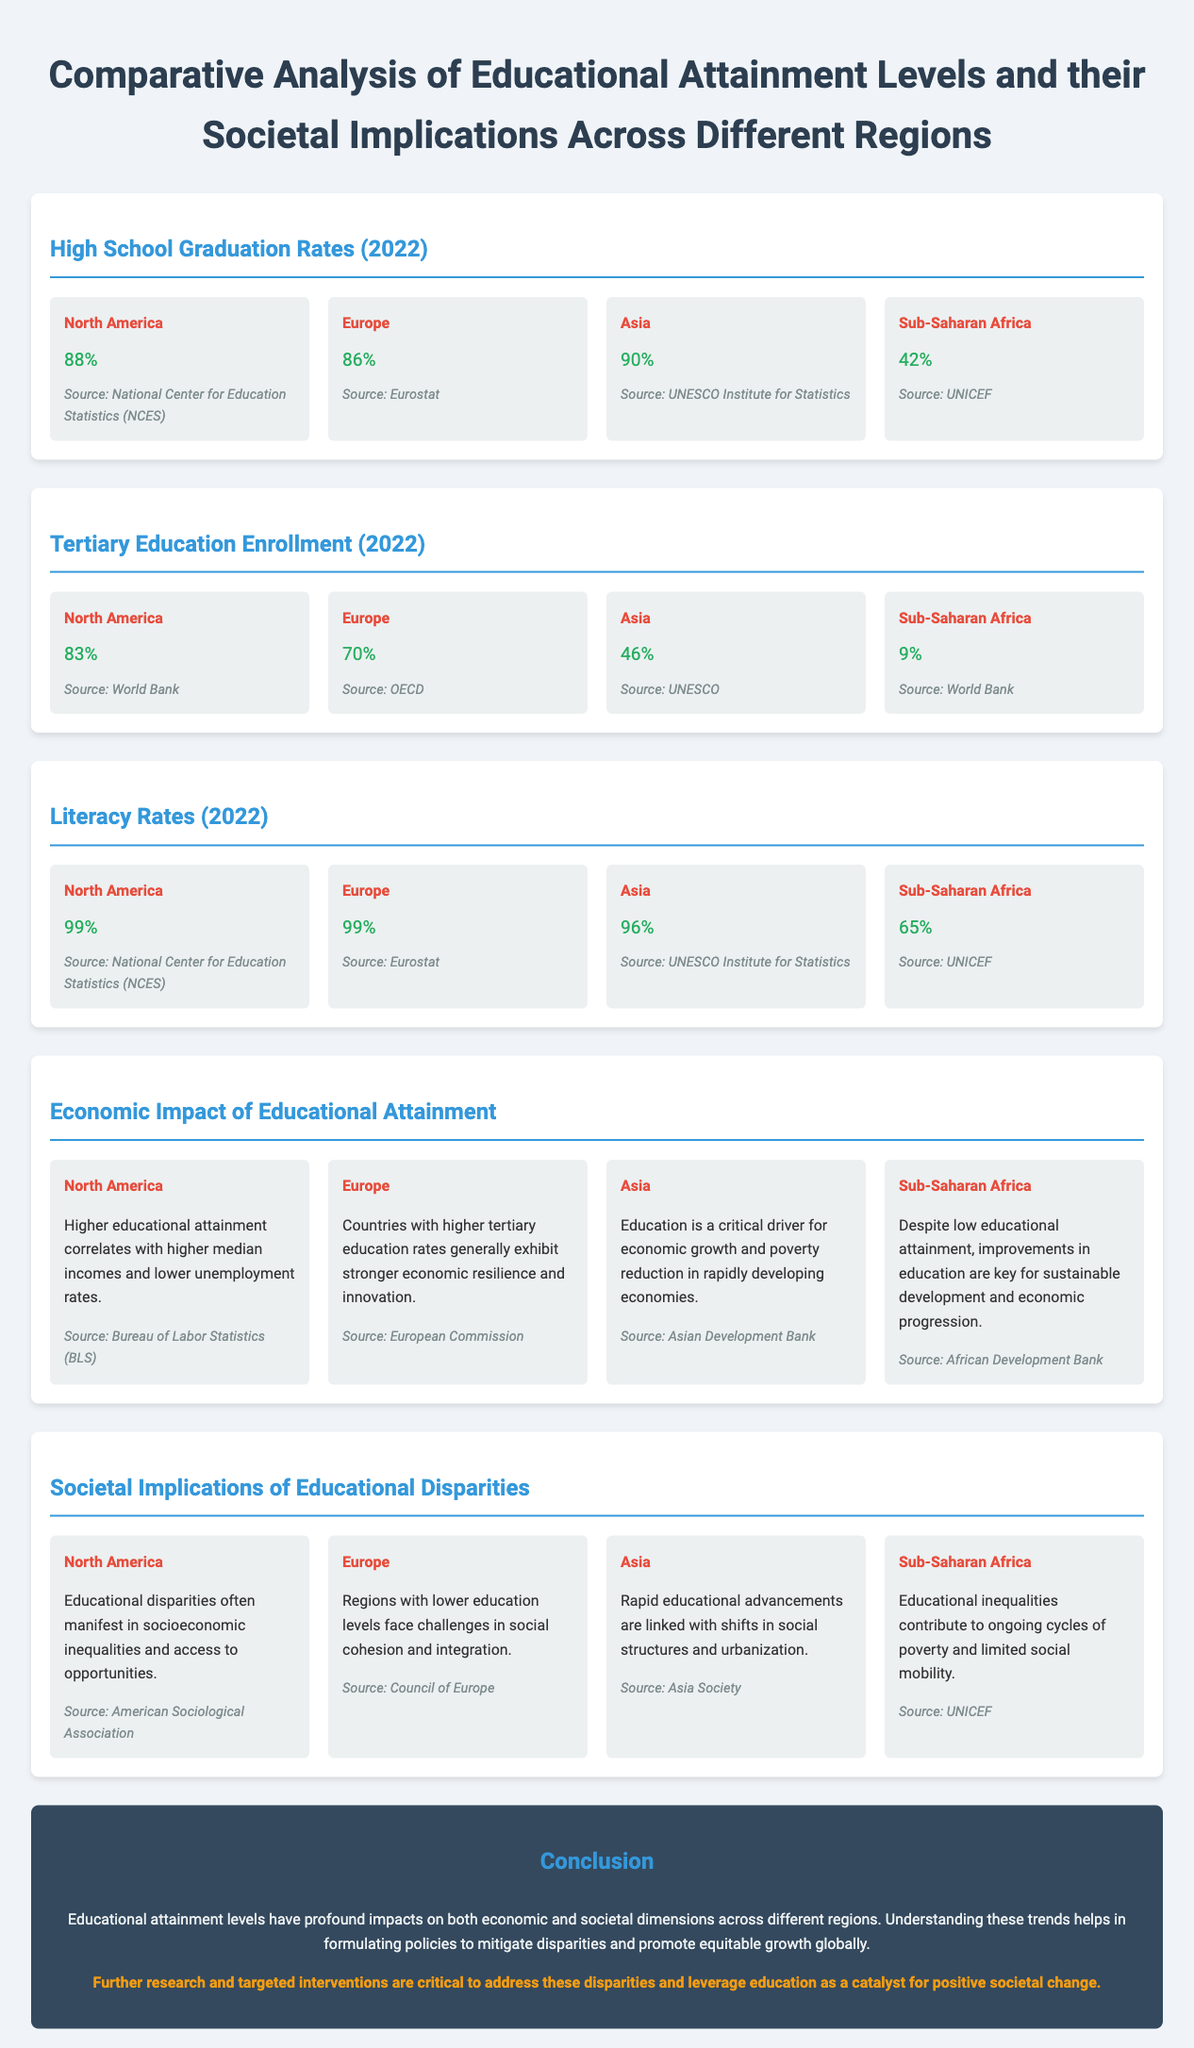What is the high school graduation rate in North America? The document states the high school graduation rate in North America is 88%.
Answer: 88% Which region has the lowest tertiary education enrollment rate? The tertiary education enrollment rate for Sub-Saharan Africa is noted as 9%, which is the lowest among the regions listed.
Answer: 9% What percentage of adults are literate in Sub-Saharan Africa? Sub-Saharan Africa's literacy rate is listed as 65% in the document.
Answer: 65% How does educational attainment impact economic growth in Asia? The document states that education is a critical driver for economic growth and poverty reduction in rapidly developing economies in Asia.
Answer: Critical driver What societal issue is associated with educational disparities in Europe? The document mentions that regions with lower education levels in Europe face challenges in social cohesion and integration.
Answer: Social cohesion What is the literacy rate in Asia? The document lists the literacy rate in Asia as 96%.
Answer: 96% Is the educational attainment in North America higher or lower compared to Europe regarding high school graduation? The document shows that North America's high school graduation rate (88%) is higher than Europe's (86%).
Answer: Higher What source is cited for the high school graduation rates? The document references the National Center for Education Statistics (NCES) as the source for high school graduation rates.
Answer: National Center for Education Statistics (NCES) What is the main conclusion about educational attainment impacts across regions? The conclusion highlights that educational attainment levels have profound impacts on both economic and societal dimensions across different regions.
Answer: Profound impacts 